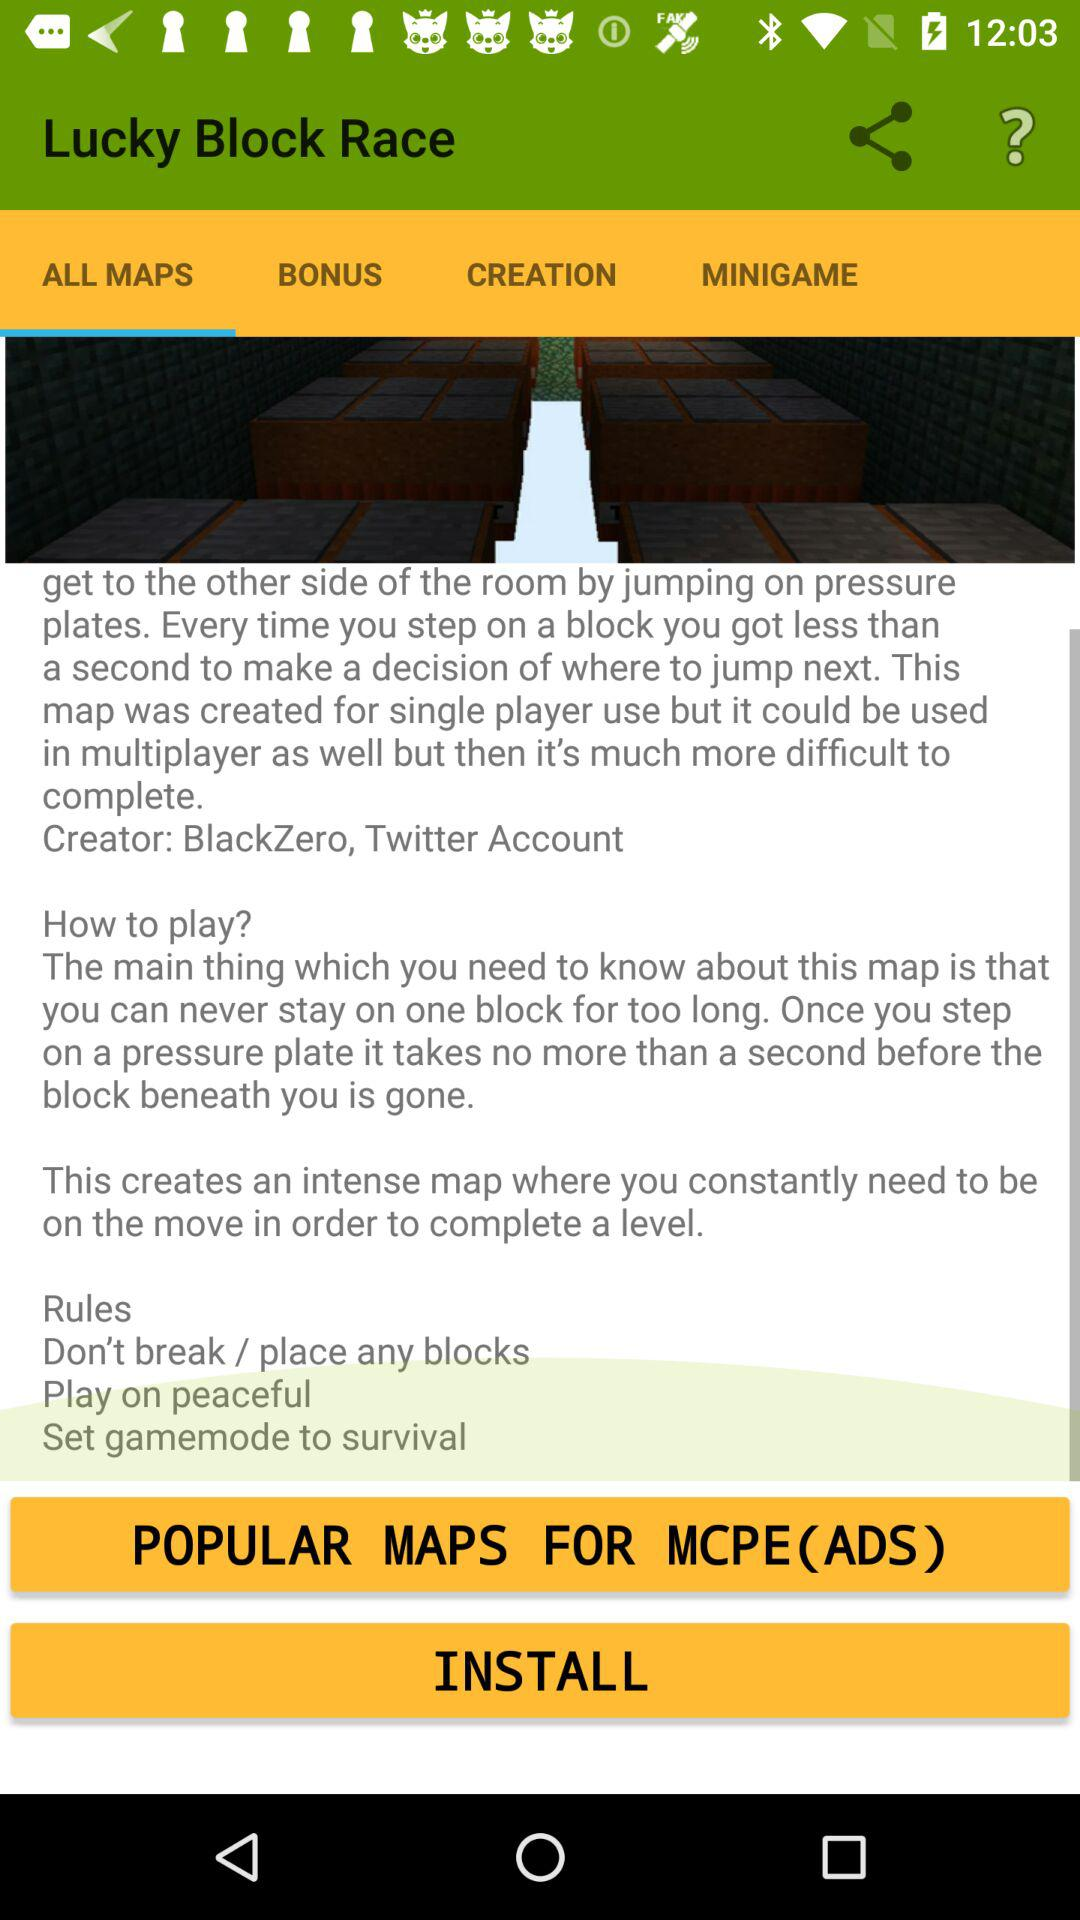What is the name of the application? The name of the application is "Lucky Block Race". 